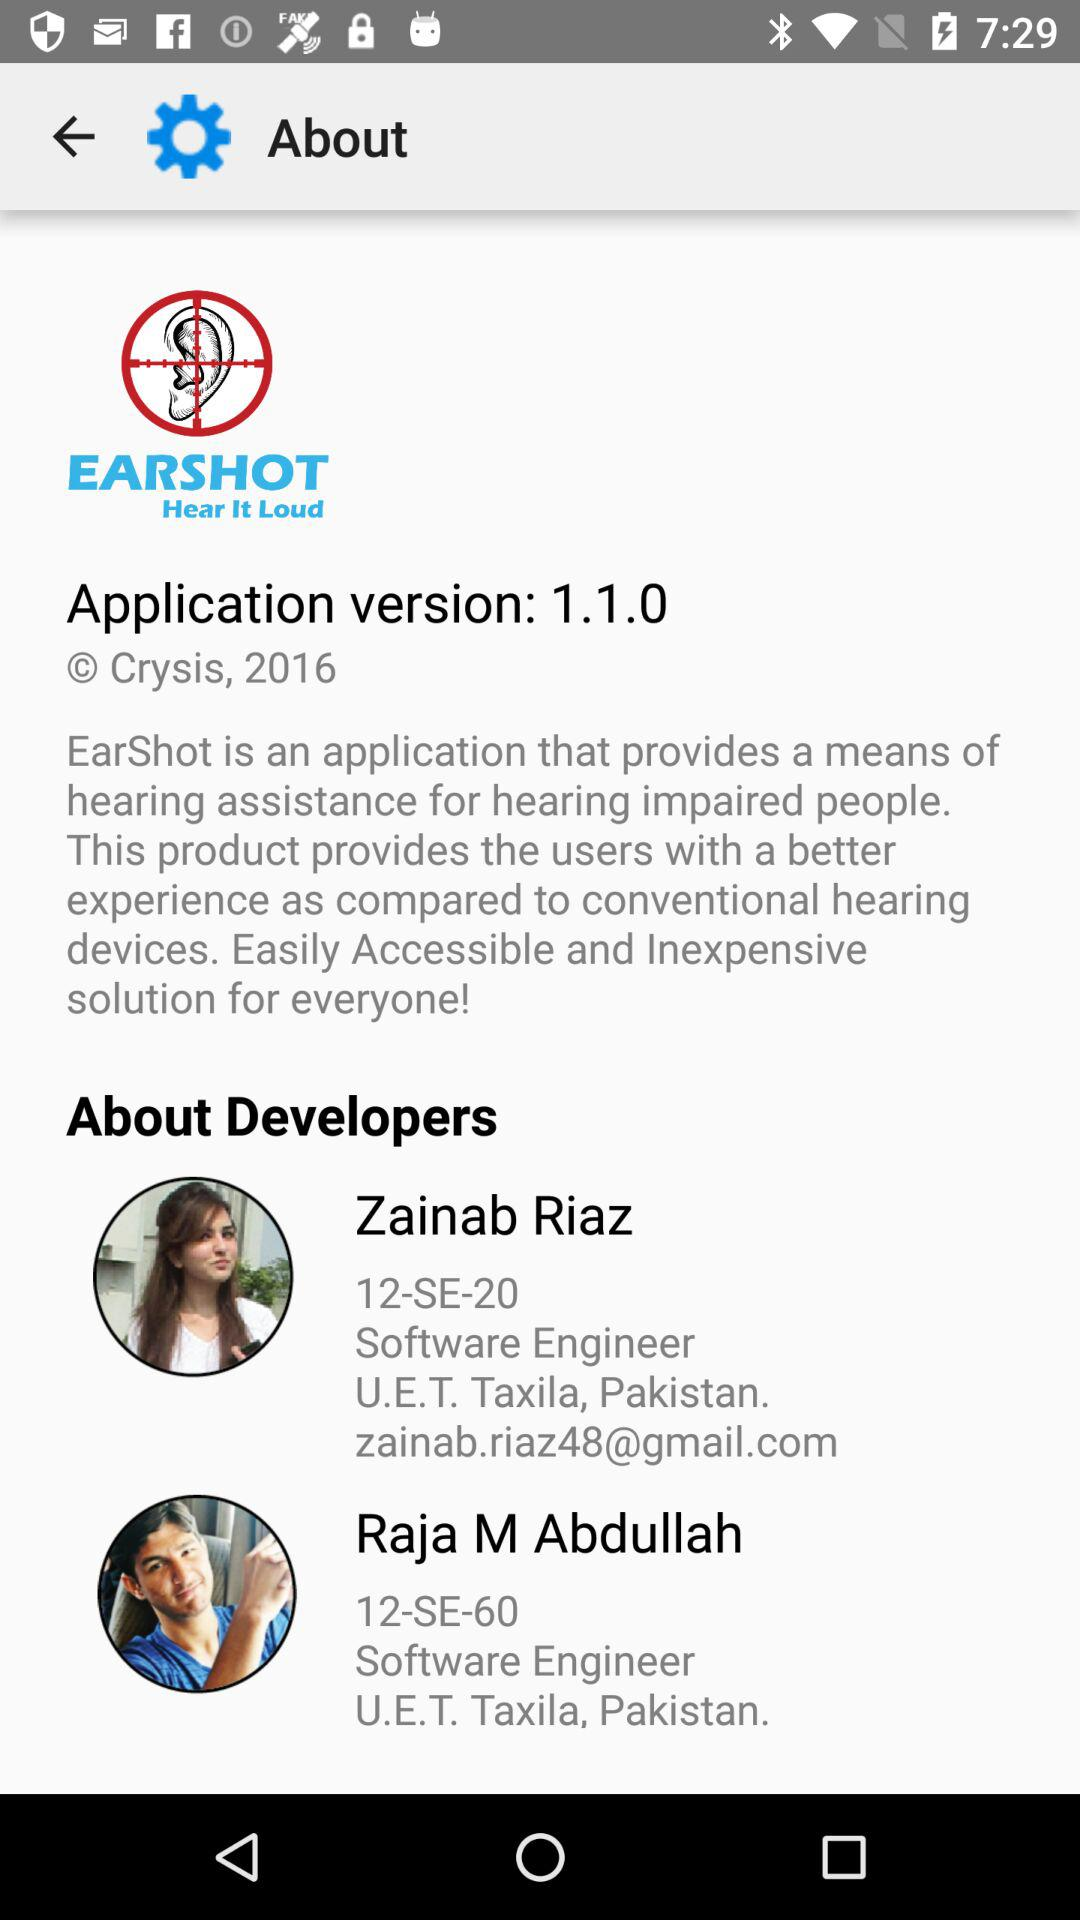What is the application version? The application version is 1.1.0. 